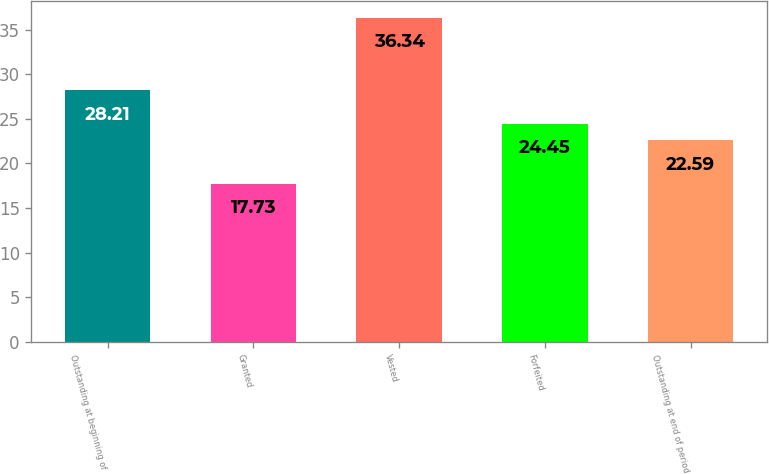<chart> <loc_0><loc_0><loc_500><loc_500><bar_chart><fcel>Outstanding at beginning of<fcel>Granted<fcel>Vested<fcel>Forfeited<fcel>Outstanding at end of period<nl><fcel>28.21<fcel>17.73<fcel>36.34<fcel>24.45<fcel>22.59<nl></chart> 